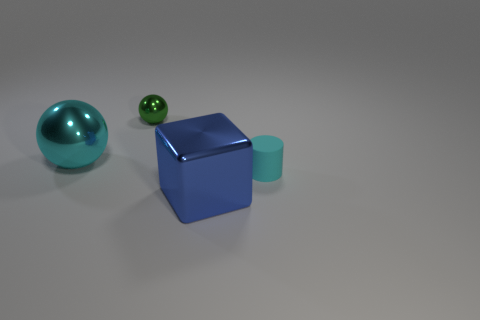What size is the ball that is the same color as the tiny rubber object? The ball that shares the same color as the tiny rubber object appears to be the large teal-colored sphere. 